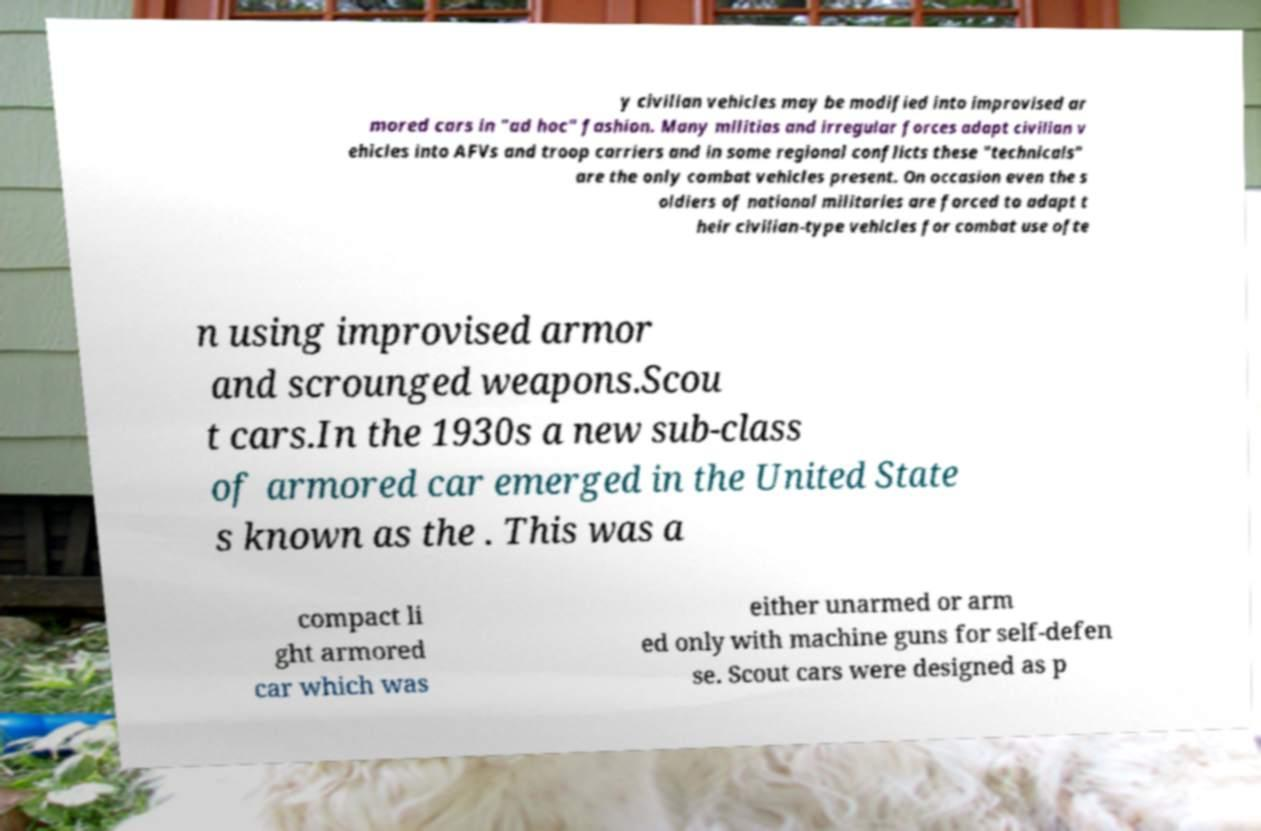Could you assist in decoding the text presented in this image and type it out clearly? y civilian vehicles may be modified into improvised ar mored cars in "ad hoc" fashion. Many militias and irregular forces adapt civilian v ehicles into AFVs and troop carriers and in some regional conflicts these "technicals" are the only combat vehicles present. On occasion even the s oldiers of national militaries are forced to adapt t heir civilian-type vehicles for combat use ofte n using improvised armor and scrounged weapons.Scou t cars.In the 1930s a new sub-class of armored car emerged in the United State s known as the . This was a compact li ght armored car which was either unarmed or arm ed only with machine guns for self-defen se. Scout cars were designed as p 